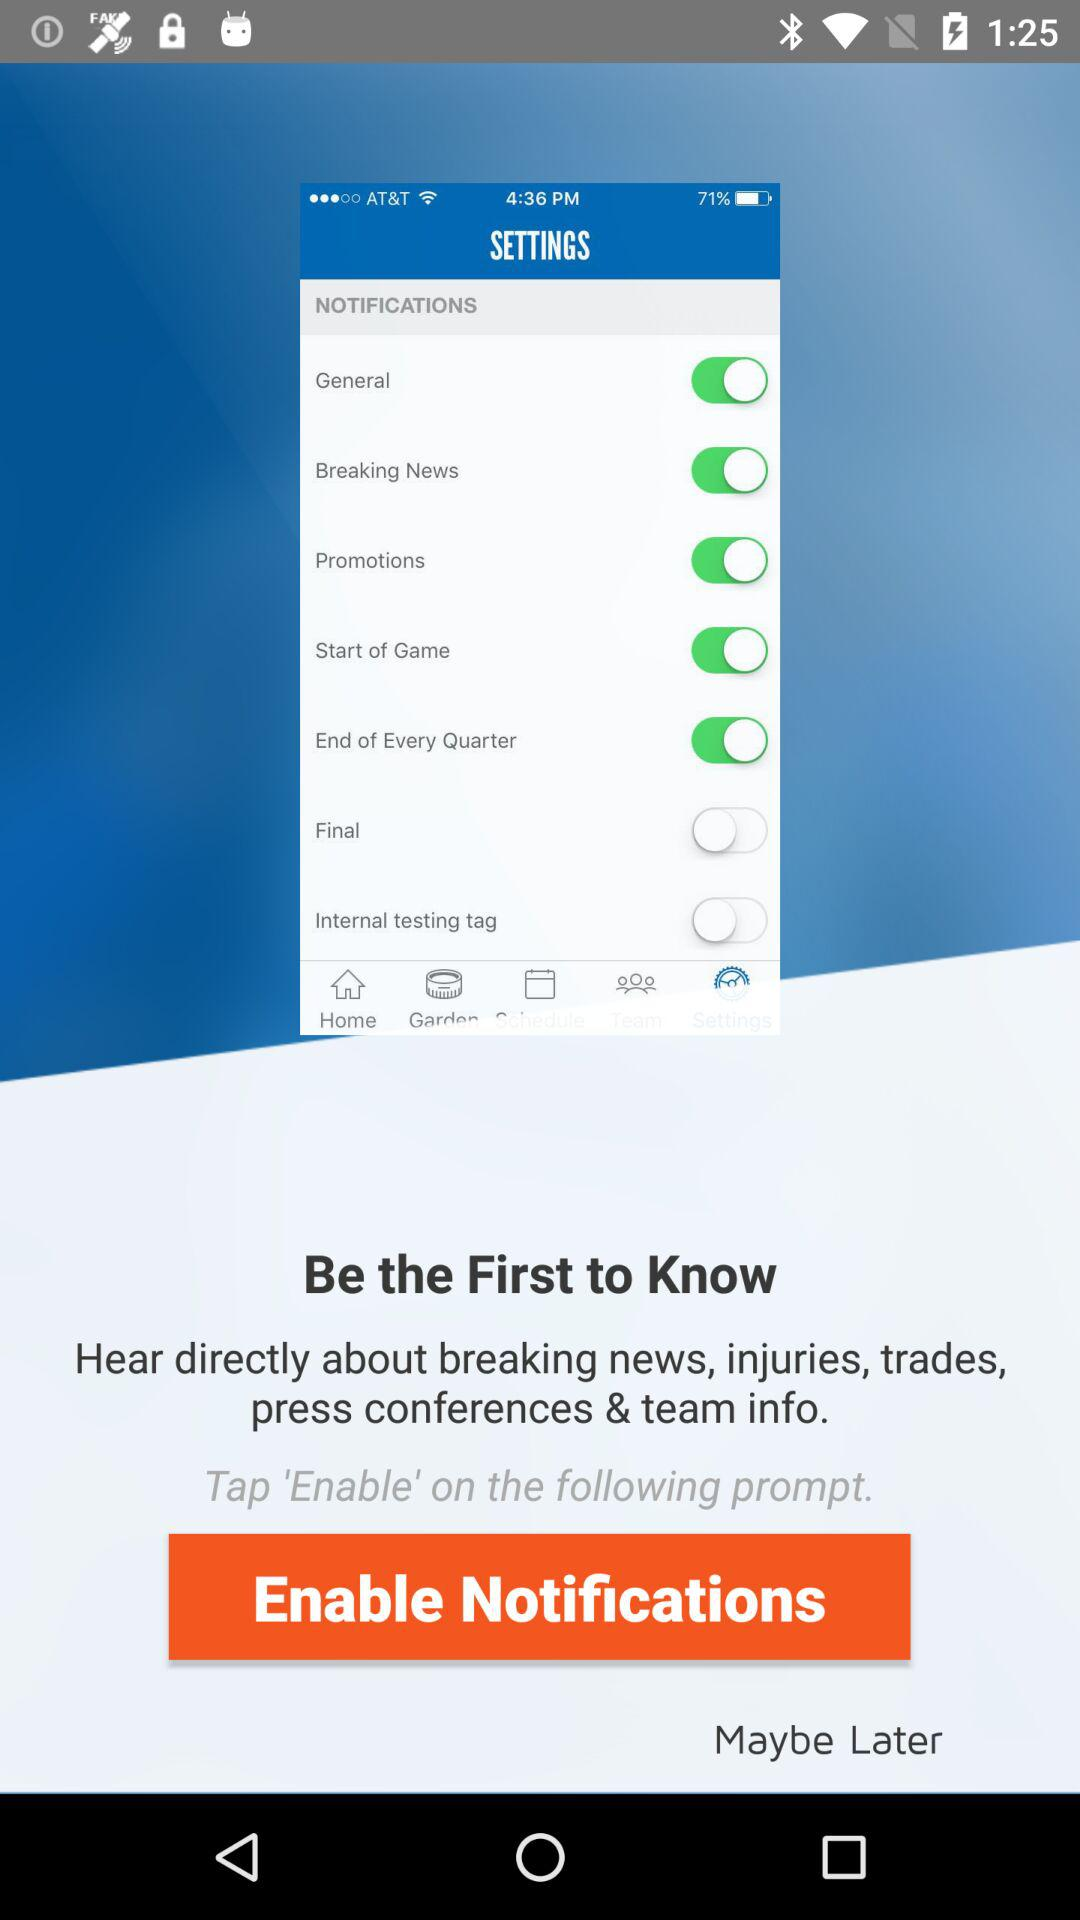What is the name of the application?
When the provided information is insufficient, respond with <no answer>. <no answer> 